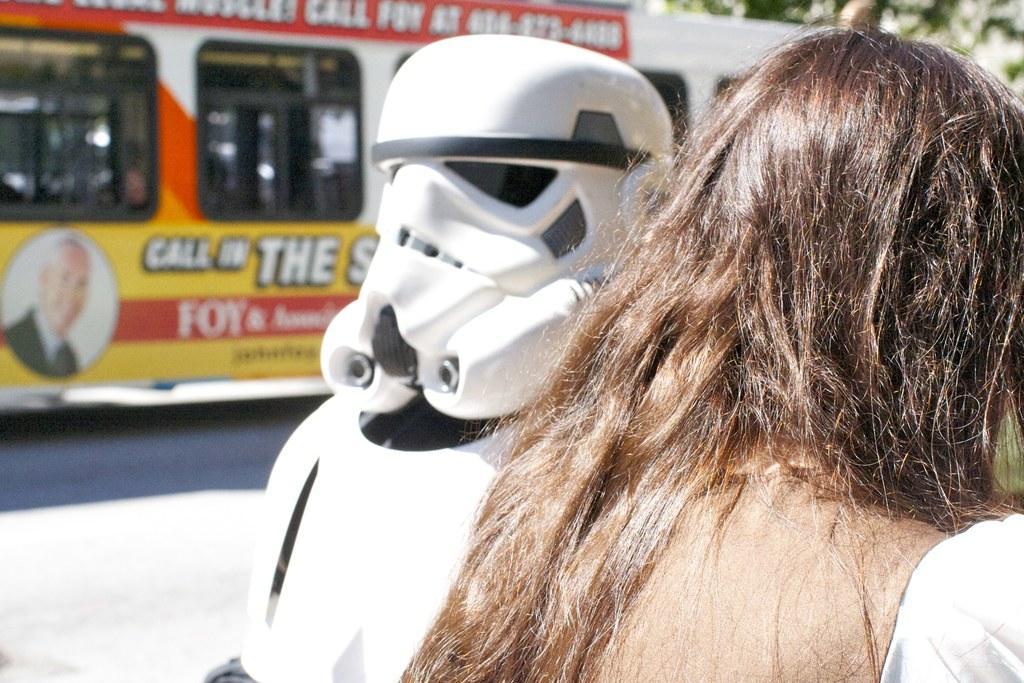Who is on the right side of the image? There is a lady on the right side of the image. What can be seen at the top side of the image? There is a bus at the top side of the image. What is located in the center of the image? There is a robot in the center of the image. What type of rod is the beginner using to pin the robot in the image? There is no rod, beginner, or pinning action present in the image. The image features a lady, a bus, and a robot, but no such activity or objects are depicted. 